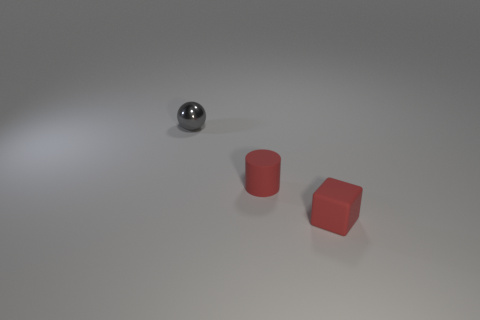Subtract all yellow balls. Subtract all green blocks. How many balls are left? 1 Add 1 tiny brown rubber objects. How many objects exist? 4 Subtract all blocks. How many objects are left? 2 Add 3 gray shiny spheres. How many gray shiny spheres are left? 4 Add 3 small matte things. How many small matte things exist? 5 Subtract 0 yellow blocks. How many objects are left? 3 Subtract all red cubes. Subtract all small gray metallic things. How many objects are left? 1 